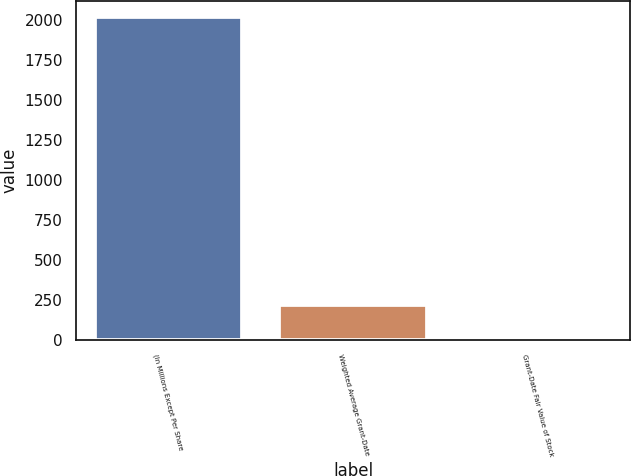Convert chart. <chart><loc_0><loc_0><loc_500><loc_500><bar_chart><fcel>(In Millions Except Per Share<fcel>Weighted Average Grant-Date<fcel>Grant-Date Fair Value of Stock<nl><fcel>2015<fcel>215.9<fcel>16<nl></chart> 